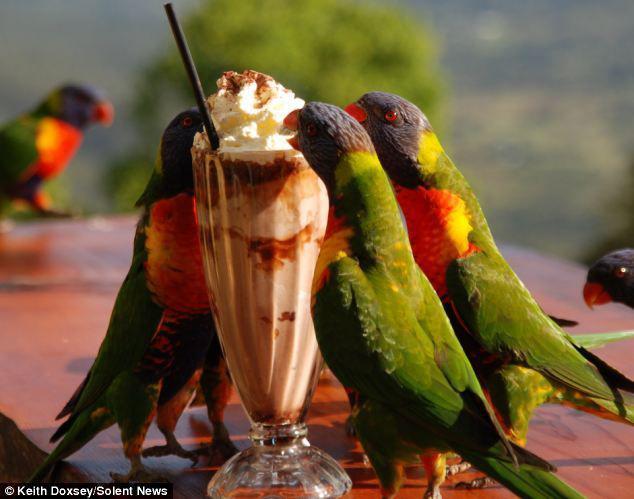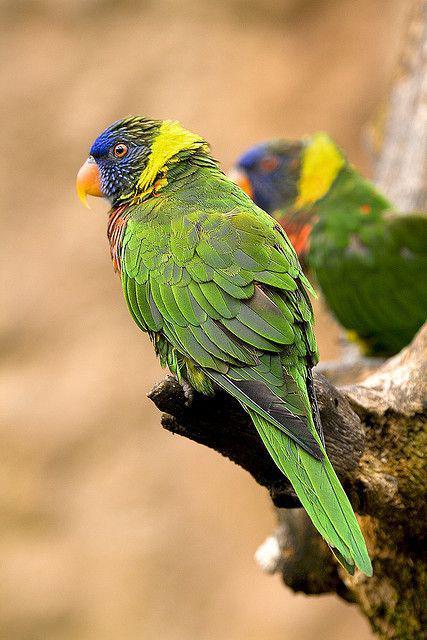The first image is the image on the left, the second image is the image on the right. Examine the images to the left and right. Is the description "One image contains at least three similarly colored parrots." accurate? Answer yes or no. Yes. 